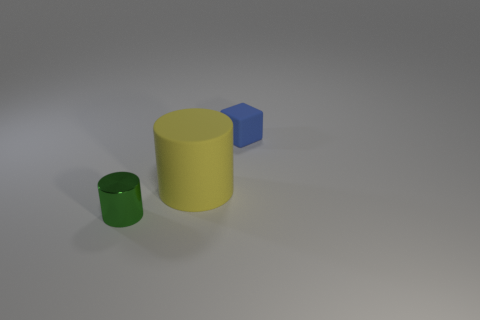Is there anything else that is made of the same material as the green thing?
Your response must be concise. No. How many cylinders are blue shiny things or green metallic things?
Your answer should be very brief. 1. The small object behind the small green metal cylinder has what shape?
Offer a terse response. Cube. What number of small blue blocks have the same material as the large thing?
Offer a very short reply. 1. Is the number of matte cylinders behind the rubber cylinder less than the number of brown cylinders?
Provide a short and direct response. No. What is the size of the object that is left of the cylinder that is behind the small green metallic thing?
Give a very brief answer. Small. There is a cylinder that is the same size as the blue object; what is its material?
Your answer should be very brief. Metal. Is the number of big yellow rubber objects left of the large thing less than the number of small objects that are to the left of the green thing?
Offer a terse response. No. The tiny object in front of the small thing behind the green cylinder is what shape?
Keep it short and to the point. Cylinder. Is there a tiny brown rubber cube?
Provide a succinct answer. No. 